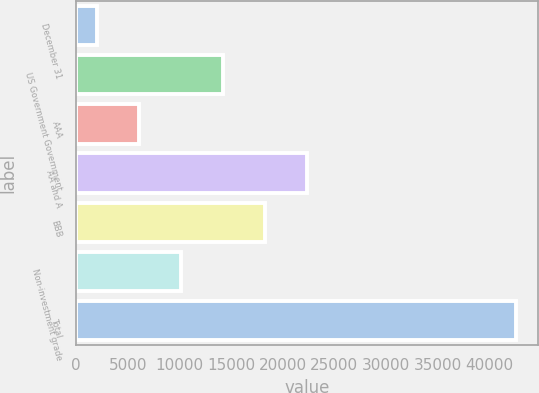<chart> <loc_0><loc_0><loc_500><loc_500><bar_chart><fcel>December 31<fcel>US Government Government<fcel>AAA<fcel>AA and A<fcel>BBB<fcel>Non-investment grade<fcel>Total<nl><fcel>2012<fcel>14198.3<fcel>6074.1<fcel>22322.5<fcel>18260.4<fcel>10136.2<fcel>42633<nl></chart> 